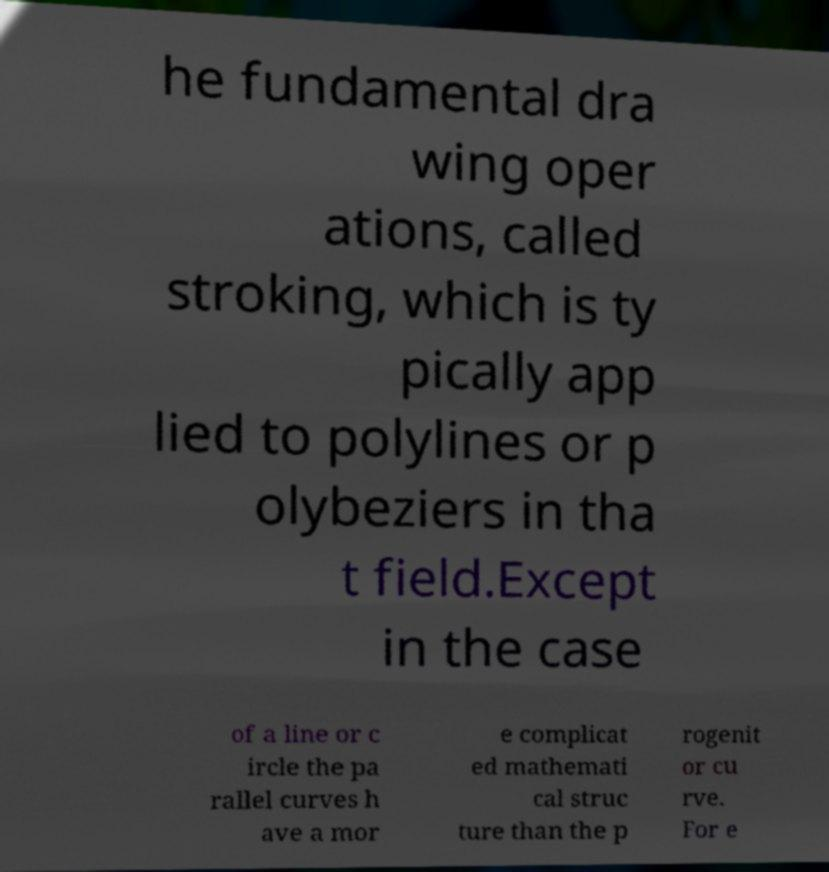Can you accurately transcribe the text from the provided image for me? he fundamental dra wing oper ations, called stroking, which is ty pically app lied to polylines or p olybeziers in tha t field.Except in the case of a line or c ircle the pa rallel curves h ave a mor e complicat ed mathemati cal struc ture than the p rogenit or cu rve. For e 